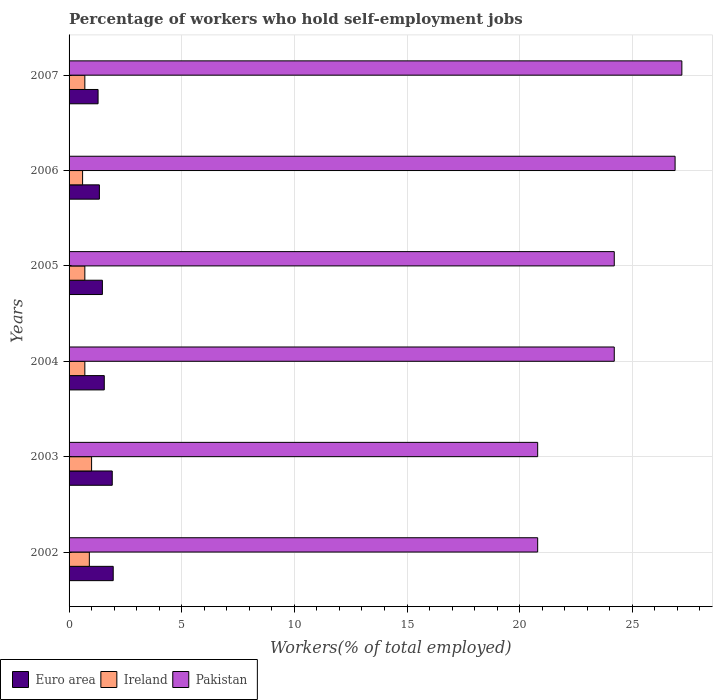How many different coloured bars are there?
Make the answer very short. 3. How many bars are there on the 2nd tick from the top?
Make the answer very short. 3. What is the percentage of self-employed workers in Pakistan in 2007?
Offer a very short reply. 27.2. Across all years, what is the minimum percentage of self-employed workers in Ireland?
Ensure brevity in your answer.  0.6. In which year was the percentage of self-employed workers in Ireland minimum?
Your answer should be compact. 2006. What is the total percentage of self-employed workers in Euro area in the graph?
Your answer should be very brief. 9.55. What is the difference between the percentage of self-employed workers in Euro area in 2003 and the percentage of self-employed workers in Ireland in 2002?
Provide a short and direct response. 1.02. What is the average percentage of self-employed workers in Euro area per year?
Give a very brief answer. 1.59. In the year 2004, what is the difference between the percentage of self-employed workers in Euro area and percentage of self-employed workers in Pakistan?
Your answer should be very brief. -22.64. What is the ratio of the percentage of self-employed workers in Pakistan in 2002 to that in 2004?
Provide a succinct answer. 0.86. Is the percentage of self-employed workers in Pakistan in 2002 less than that in 2006?
Offer a very short reply. Yes. What is the difference between the highest and the second highest percentage of self-employed workers in Ireland?
Ensure brevity in your answer.  0.1. What is the difference between the highest and the lowest percentage of self-employed workers in Euro area?
Ensure brevity in your answer.  0.67. What does the 1st bar from the bottom in 2006 represents?
Your answer should be very brief. Euro area. How many bars are there?
Make the answer very short. 18. Does the graph contain grids?
Your answer should be very brief. Yes. Where does the legend appear in the graph?
Your answer should be compact. Bottom left. What is the title of the graph?
Give a very brief answer. Percentage of workers who hold self-employment jobs. What is the label or title of the X-axis?
Your answer should be very brief. Workers(% of total employed). What is the label or title of the Y-axis?
Your answer should be compact. Years. What is the Workers(% of total employed) in Euro area in 2002?
Your response must be concise. 1.96. What is the Workers(% of total employed) of Ireland in 2002?
Ensure brevity in your answer.  0.9. What is the Workers(% of total employed) in Pakistan in 2002?
Offer a terse response. 20.8. What is the Workers(% of total employed) in Euro area in 2003?
Ensure brevity in your answer.  1.92. What is the Workers(% of total employed) of Pakistan in 2003?
Your answer should be very brief. 20.8. What is the Workers(% of total employed) of Euro area in 2004?
Give a very brief answer. 1.56. What is the Workers(% of total employed) of Ireland in 2004?
Make the answer very short. 0.7. What is the Workers(% of total employed) in Pakistan in 2004?
Ensure brevity in your answer.  24.2. What is the Workers(% of total employed) of Euro area in 2005?
Provide a short and direct response. 1.48. What is the Workers(% of total employed) of Ireland in 2005?
Make the answer very short. 0.7. What is the Workers(% of total employed) in Pakistan in 2005?
Provide a short and direct response. 24.2. What is the Workers(% of total employed) of Euro area in 2006?
Make the answer very short. 1.35. What is the Workers(% of total employed) in Ireland in 2006?
Your answer should be compact. 0.6. What is the Workers(% of total employed) of Pakistan in 2006?
Your answer should be very brief. 26.9. What is the Workers(% of total employed) of Euro area in 2007?
Provide a succinct answer. 1.29. What is the Workers(% of total employed) of Ireland in 2007?
Make the answer very short. 0.7. What is the Workers(% of total employed) of Pakistan in 2007?
Your answer should be compact. 27.2. Across all years, what is the maximum Workers(% of total employed) of Euro area?
Ensure brevity in your answer.  1.96. Across all years, what is the maximum Workers(% of total employed) of Pakistan?
Offer a very short reply. 27.2. Across all years, what is the minimum Workers(% of total employed) of Euro area?
Offer a terse response. 1.29. Across all years, what is the minimum Workers(% of total employed) of Ireland?
Provide a short and direct response. 0.6. Across all years, what is the minimum Workers(% of total employed) of Pakistan?
Keep it short and to the point. 20.8. What is the total Workers(% of total employed) in Euro area in the graph?
Give a very brief answer. 9.55. What is the total Workers(% of total employed) of Ireland in the graph?
Provide a succinct answer. 4.6. What is the total Workers(% of total employed) in Pakistan in the graph?
Ensure brevity in your answer.  144.1. What is the difference between the Workers(% of total employed) in Euro area in 2002 and that in 2003?
Your response must be concise. 0.04. What is the difference between the Workers(% of total employed) of Pakistan in 2002 and that in 2003?
Ensure brevity in your answer.  0. What is the difference between the Workers(% of total employed) in Euro area in 2002 and that in 2004?
Keep it short and to the point. 0.4. What is the difference between the Workers(% of total employed) of Euro area in 2002 and that in 2005?
Your answer should be very brief. 0.48. What is the difference between the Workers(% of total employed) in Euro area in 2002 and that in 2006?
Provide a short and direct response. 0.61. What is the difference between the Workers(% of total employed) in Pakistan in 2002 and that in 2006?
Your answer should be very brief. -6.1. What is the difference between the Workers(% of total employed) in Euro area in 2002 and that in 2007?
Your answer should be compact. 0.67. What is the difference between the Workers(% of total employed) of Ireland in 2002 and that in 2007?
Provide a short and direct response. 0.2. What is the difference between the Workers(% of total employed) in Pakistan in 2002 and that in 2007?
Your answer should be very brief. -6.4. What is the difference between the Workers(% of total employed) of Euro area in 2003 and that in 2004?
Provide a short and direct response. 0.35. What is the difference between the Workers(% of total employed) of Ireland in 2003 and that in 2004?
Provide a short and direct response. 0.3. What is the difference between the Workers(% of total employed) in Euro area in 2003 and that in 2005?
Your answer should be compact. 0.44. What is the difference between the Workers(% of total employed) in Ireland in 2003 and that in 2005?
Ensure brevity in your answer.  0.3. What is the difference between the Workers(% of total employed) of Pakistan in 2003 and that in 2005?
Give a very brief answer. -3.4. What is the difference between the Workers(% of total employed) in Euro area in 2003 and that in 2006?
Your response must be concise. 0.57. What is the difference between the Workers(% of total employed) in Euro area in 2003 and that in 2007?
Offer a very short reply. 0.63. What is the difference between the Workers(% of total employed) in Euro area in 2004 and that in 2005?
Offer a terse response. 0.08. What is the difference between the Workers(% of total employed) in Ireland in 2004 and that in 2005?
Your answer should be compact. 0. What is the difference between the Workers(% of total employed) of Euro area in 2004 and that in 2006?
Offer a very short reply. 0.22. What is the difference between the Workers(% of total employed) of Ireland in 2004 and that in 2006?
Make the answer very short. 0.1. What is the difference between the Workers(% of total employed) in Pakistan in 2004 and that in 2006?
Make the answer very short. -2.7. What is the difference between the Workers(% of total employed) in Euro area in 2004 and that in 2007?
Offer a terse response. 0.28. What is the difference between the Workers(% of total employed) in Pakistan in 2004 and that in 2007?
Give a very brief answer. -3. What is the difference between the Workers(% of total employed) in Euro area in 2005 and that in 2006?
Offer a very short reply. 0.13. What is the difference between the Workers(% of total employed) in Ireland in 2005 and that in 2006?
Give a very brief answer. 0.1. What is the difference between the Workers(% of total employed) of Euro area in 2005 and that in 2007?
Your response must be concise. 0.19. What is the difference between the Workers(% of total employed) in Ireland in 2005 and that in 2007?
Your response must be concise. 0. What is the difference between the Workers(% of total employed) of Euro area in 2006 and that in 2007?
Your answer should be very brief. 0.06. What is the difference between the Workers(% of total employed) in Ireland in 2006 and that in 2007?
Provide a short and direct response. -0.1. What is the difference between the Workers(% of total employed) of Euro area in 2002 and the Workers(% of total employed) of Ireland in 2003?
Provide a succinct answer. 0.96. What is the difference between the Workers(% of total employed) of Euro area in 2002 and the Workers(% of total employed) of Pakistan in 2003?
Your answer should be compact. -18.84. What is the difference between the Workers(% of total employed) of Ireland in 2002 and the Workers(% of total employed) of Pakistan in 2003?
Your answer should be compact. -19.9. What is the difference between the Workers(% of total employed) of Euro area in 2002 and the Workers(% of total employed) of Ireland in 2004?
Keep it short and to the point. 1.26. What is the difference between the Workers(% of total employed) of Euro area in 2002 and the Workers(% of total employed) of Pakistan in 2004?
Your answer should be compact. -22.24. What is the difference between the Workers(% of total employed) in Ireland in 2002 and the Workers(% of total employed) in Pakistan in 2004?
Offer a terse response. -23.3. What is the difference between the Workers(% of total employed) of Euro area in 2002 and the Workers(% of total employed) of Ireland in 2005?
Your answer should be compact. 1.26. What is the difference between the Workers(% of total employed) of Euro area in 2002 and the Workers(% of total employed) of Pakistan in 2005?
Give a very brief answer. -22.24. What is the difference between the Workers(% of total employed) in Ireland in 2002 and the Workers(% of total employed) in Pakistan in 2005?
Offer a terse response. -23.3. What is the difference between the Workers(% of total employed) in Euro area in 2002 and the Workers(% of total employed) in Ireland in 2006?
Your answer should be compact. 1.36. What is the difference between the Workers(% of total employed) in Euro area in 2002 and the Workers(% of total employed) in Pakistan in 2006?
Your answer should be compact. -24.94. What is the difference between the Workers(% of total employed) in Ireland in 2002 and the Workers(% of total employed) in Pakistan in 2006?
Your answer should be very brief. -26. What is the difference between the Workers(% of total employed) in Euro area in 2002 and the Workers(% of total employed) in Ireland in 2007?
Keep it short and to the point. 1.26. What is the difference between the Workers(% of total employed) in Euro area in 2002 and the Workers(% of total employed) in Pakistan in 2007?
Provide a succinct answer. -25.24. What is the difference between the Workers(% of total employed) of Ireland in 2002 and the Workers(% of total employed) of Pakistan in 2007?
Offer a terse response. -26.3. What is the difference between the Workers(% of total employed) in Euro area in 2003 and the Workers(% of total employed) in Ireland in 2004?
Make the answer very short. 1.22. What is the difference between the Workers(% of total employed) in Euro area in 2003 and the Workers(% of total employed) in Pakistan in 2004?
Make the answer very short. -22.28. What is the difference between the Workers(% of total employed) in Ireland in 2003 and the Workers(% of total employed) in Pakistan in 2004?
Give a very brief answer. -23.2. What is the difference between the Workers(% of total employed) in Euro area in 2003 and the Workers(% of total employed) in Ireland in 2005?
Give a very brief answer. 1.22. What is the difference between the Workers(% of total employed) of Euro area in 2003 and the Workers(% of total employed) of Pakistan in 2005?
Provide a succinct answer. -22.28. What is the difference between the Workers(% of total employed) in Ireland in 2003 and the Workers(% of total employed) in Pakistan in 2005?
Offer a terse response. -23.2. What is the difference between the Workers(% of total employed) of Euro area in 2003 and the Workers(% of total employed) of Ireland in 2006?
Your answer should be compact. 1.32. What is the difference between the Workers(% of total employed) in Euro area in 2003 and the Workers(% of total employed) in Pakistan in 2006?
Provide a succinct answer. -24.98. What is the difference between the Workers(% of total employed) of Ireland in 2003 and the Workers(% of total employed) of Pakistan in 2006?
Your response must be concise. -25.9. What is the difference between the Workers(% of total employed) of Euro area in 2003 and the Workers(% of total employed) of Ireland in 2007?
Your response must be concise. 1.22. What is the difference between the Workers(% of total employed) of Euro area in 2003 and the Workers(% of total employed) of Pakistan in 2007?
Give a very brief answer. -25.28. What is the difference between the Workers(% of total employed) in Ireland in 2003 and the Workers(% of total employed) in Pakistan in 2007?
Make the answer very short. -26.2. What is the difference between the Workers(% of total employed) of Euro area in 2004 and the Workers(% of total employed) of Ireland in 2005?
Offer a very short reply. 0.86. What is the difference between the Workers(% of total employed) of Euro area in 2004 and the Workers(% of total employed) of Pakistan in 2005?
Keep it short and to the point. -22.64. What is the difference between the Workers(% of total employed) in Ireland in 2004 and the Workers(% of total employed) in Pakistan in 2005?
Offer a terse response. -23.5. What is the difference between the Workers(% of total employed) of Euro area in 2004 and the Workers(% of total employed) of Ireland in 2006?
Provide a succinct answer. 0.96. What is the difference between the Workers(% of total employed) in Euro area in 2004 and the Workers(% of total employed) in Pakistan in 2006?
Make the answer very short. -25.34. What is the difference between the Workers(% of total employed) in Ireland in 2004 and the Workers(% of total employed) in Pakistan in 2006?
Provide a succinct answer. -26.2. What is the difference between the Workers(% of total employed) of Euro area in 2004 and the Workers(% of total employed) of Ireland in 2007?
Ensure brevity in your answer.  0.86. What is the difference between the Workers(% of total employed) in Euro area in 2004 and the Workers(% of total employed) in Pakistan in 2007?
Provide a short and direct response. -25.64. What is the difference between the Workers(% of total employed) of Ireland in 2004 and the Workers(% of total employed) of Pakistan in 2007?
Ensure brevity in your answer.  -26.5. What is the difference between the Workers(% of total employed) in Euro area in 2005 and the Workers(% of total employed) in Ireland in 2006?
Give a very brief answer. 0.88. What is the difference between the Workers(% of total employed) of Euro area in 2005 and the Workers(% of total employed) of Pakistan in 2006?
Ensure brevity in your answer.  -25.42. What is the difference between the Workers(% of total employed) of Ireland in 2005 and the Workers(% of total employed) of Pakistan in 2006?
Your answer should be compact. -26.2. What is the difference between the Workers(% of total employed) in Euro area in 2005 and the Workers(% of total employed) in Ireland in 2007?
Offer a terse response. 0.78. What is the difference between the Workers(% of total employed) of Euro area in 2005 and the Workers(% of total employed) of Pakistan in 2007?
Offer a terse response. -25.72. What is the difference between the Workers(% of total employed) of Ireland in 2005 and the Workers(% of total employed) of Pakistan in 2007?
Give a very brief answer. -26.5. What is the difference between the Workers(% of total employed) of Euro area in 2006 and the Workers(% of total employed) of Ireland in 2007?
Give a very brief answer. 0.65. What is the difference between the Workers(% of total employed) in Euro area in 2006 and the Workers(% of total employed) in Pakistan in 2007?
Your answer should be compact. -25.85. What is the difference between the Workers(% of total employed) of Ireland in 2006 and the Workers(% of total employed) of Pakistan in 2007?
Offer a terse response. -26.6. What is the average Workers(% of total employed) of Euro area per year?
Offer a very short reply. 1.59. What is the average Workers(% of total employed) of Ireland per year?
Offer a terse response. 0.77. What is the average Workers(% of total employed) in Pakistan per year?
Offer a terse response. 24.02. In the year 2002, what is the difference between the Workers(% of total employed) of Euro area and Workers(% of total employed) of Ireland?
Offer a very short reply. 1.06. In the year 2002, what is the difference between the Workers(% of total employed) of Euro area and Workers(% of total employed) of Pakistan?
Offer a terse response. -18.84. In the year 2002, what is the difference between the Workers(% of total employed) of Ireland and Workers(% of total employed) of Pakistan?
Keep it short and to the point. -19.9. In the year 2003, what is the difference between the Workers(% of total employed) of Euro area and Workers(% of total employed) of Ireland?
Offer a very short reply. 0.92. In the year 2003, what is the difference between the Workers(% of total employed) of Euro area and Workers(% of total employed) of Pakistan?
Your answer should be very brief. -18.88. In the year 2003, what is the difference between the Workers(% of total employed) in Ireland and Workers(% of total employed) in Pakistan?
Offer a terse response. -19.8. In the year 2004, what is the difference between the Workers(% of total employed) of Euro area and Workers(% of total employed) of Ireland?
Your answer should be compact. 0.86. In the year 2004, what is the difference between the Workers(% of total employed) of Euro area and Workers(% of total employed) of Pakistan?
Your response must be concise. -22.64. In the year 2004, what is the difference between the Workers(% of total employed) of Ireland and Workers(% of total employed) of Pakistan?
Keep it short and to the point. -23.5. In the year 2005, what is the difference between the Workers(% of total employed) in Euro area and Workers(% of total employed) in Ireland?
Your answer should be compact. 0.78. In the year 2005, what is the difference between the Workers(% of total employed) of Euro area and Workers(% of total employed) of Pakistan?
Your answer should be compact. -22.72. In the year 2005, what is the difference between the Workers(% of total employed) of Ireland and Workers(% of total employed) of Pakistan?
Offer a terse response. -23.5. In the year 2006, what is the difference between the Workers(% of total employed) of Euro area and Workers(% of total employed) of Ireland?
Ensure brevity in your answer.  0.75. In the year 2006, what is the difference between the Workers(% of total employed) in Euro area and Workers(% of total employed) in Pakistan?
Ensure brevity in your answer.  -25.55. In the year 2006, what is the difference between the Workers(% of total employed) in Ireland and Workers(% of total employed) in Pakistan?
Provide a succinct answer. -26.3. In the year 2007, what is the difference between the Workers(% of total employed) in Euro area and Workers(% of total employed) in Ireland?
Your answer should be compact. 0.59. In the year 2007, what is the difference between the Workers(% of total employed) of Euro area and Workers(% of total employed) of Pakistan?
Make the answer very short. -25.91. In the year 2007, what is the difference between the Workers(% of total employed) in Ireland and Workers(% of total employed) in Pakistan?
Keep it short and to the point. -26.5. What is the ratio of the Workers(% of total employed) in Euro area in 2002 to that in 2003?
Offer a terse response. 1.02. What is the ratio of the Workers(% of total employed) of Ireland in 2002 to that in 2003?
Offer a terse response. 0.9. What is the ratio of the Workers(% of total employed) in Pakistan in 2002 to that in 2003?
Keep it short and to the point. 1. What is the ratio of the Workers(% of total employed) of Euro area in 2002 to that in 2004?
Provide a succinct answer. 1.25. What is the ratio of the Workers(% of total employed) in Pakistan in 2002 to that in 2004?
Provide a short and direct response. 0.86. What is the ratio of the Workers(% of total employed) of Euro area in 2002 to that in 2005?
Make the answer very short. 1.33. What is the ratio of the Workers(% of total employed) in Ireland in 2002 to that in 2005?
Ensure brevity in your answer.  1.29. What is the ratio of the Workers(% of total employed) in Pakistan in 2002 to that in 2005?
Make the answer very short. 0.86. What is the ratio of the Workers(% of total employed) in Euro area in 2002 to that in 2006?
Make the answer very short. 1.46. What is the ratio of the Workers(% of total employed) in Pakistan in 2002 to that in 2006?
Offer a terse response. 0.77. What is the ratio of the Workers(% of total employed) in Euro area in 2002 to that in 2007?
Make the answer very short. 1.52. What is the ratio of the Workers(% of total employed) of Ireland in 2002 to that in 2007?
Keep it short and to the point. 1.29. What is the ratio of the Workers(% of total employed) in Pakistan in 2002 to that in 2007?
Provide a short and direct response. 0.76. What is the ratio of the Workers(% of total employed) in Euro area in 2003 to that in 2004?
Your answer should be compact. 1.23. What is the ratio of the Workers(% of total employed) in Ireland in 2003 to that in 2004?
Provide a short and direct response. 1.43. What is the ratio of the Workers(% of total employed) in Pakistan in 2003 to that in 2004?
Your answer should be very brief. 0.86. What is the ratio of the Workers(% of total employed) of Euro area in 2003 to that in 2005?
Ensure brevity in your answer.  1.3. What is the ratio of the Workers(% of total employed) in Ireland in 2003 to that in 2005?
Ensure brevity in your answer.  1.43. What is the ratio of the Workers(% of total employed) in Pakistan in 2003 to that in 2005?
Offer a terse response. 0.86. What is the ratio of the Workers(% of total employed) in Euro area in 2003 to that in 2006?
Ensure brevity in your answer.  1.42. What is the ratio of the Workers(% of total employed) in Ireland in 2003 to that in 2006?
Provide a succinct answer. 1.67. What is the ratio of the Workers(% of total employed) of Pakistan in 2003 to that in 2006?
Keep it short and to the point. 0.77. What is the ratio of the Workers(% of total employed) in Euro area in 2003 to that in 2007?
Your answer should be compact. 1.49. What is the ratio of the Workers(% of total employed) in Ireland in 2003 to that in 2007?
Keep it short and to the point. 1.43. What is the ratio of the Workers(% of total employed) of Pakistan in 2003 to that in 2007?
Your response must be concise. 0.76. What is the ratio of the Workers(% of total employed) in Euro area in 2004 to that in 2005?
Keep it short and to the point. 1.06. What is the ratio of the Workers(% of total employed) of Pakistan in 2004 to that in 2005?
Your answer should be compact. 1. What is the ratio of the Workers(% of total employed) in Euro area in 2004 to that in 2006?
Ensure brevity in your answer.  1.16. What is the ratio of the Workers(% of total employed) in Ireland in 2004 to that in 2006?
Make the answer very short. 1.17. What is the ratio of the Workers(% of total employed) in Pakistan in 2004 to that in 2006?
Your response must be concise. 0.9. What is the ratio of the Workers(% of total employed) in Euro area in 2004 to that in 2007?
Your response must be concise. 1.21. What is the ratio of the Workers(% of total employed) in Pakistan in 2004 to that in 2007?
Offer a terse response. 0.89. What is the ratio of the Workers(% of total employed) in Euro area in 2005 to that in 2006?
Your answer should be compact. 1.1. What is the ratio of the Workers(% of total employed) of Ireland in 2005 to that in 2006?
Your response must be concise. 1.17. What is the ratio of the Workers(% of total employed) of Pakistan in 2005 to that in 2006?
Provide a succinct answer. 0.9. What is the ratio of the Workers(% of total employed) of Euro area in 2005 to that in 2007?
Ensure brevity in your answer.  1.15. What is the ratio of the Workers(% of total employed) of Pakistan in 2005 to that in 2007?
Offer a terse response. 0.89. What is the ratio of the Workers(% of total employed) in Euro area in 2006 to that in 2007?
Make the answer very short. 1.05. What is the ratio of the Workers(% of total employed) in Ireland in 2006 to that in 2007?
Your answer should be very brief. 0.86. What is the ratio of the Workers(% of total employed) in Pakistan in 2006 to that in 2007?
Make the answer very short. 0.99. What is the difference between the highest and the second highest Workers(% of total employed) in Euro area?
Offer a very short reply. 0.04. What is the difference between the highest and the second highest Workers(% of total employed) in Pakistan?
Offer a terse response. 0.3. What is the difference between the highest and the lowest Workers(% of total employed) of Euro area?
Your answer should be compact. 0.67. What is the difference between the highest and the lowest Workers(% of total employed) in Ireland?
Ensure brevity in your answer.  0.4. What is the difference between the highest and the lowest Workers(% of total employed) of Pakistan?
Offer a terse response. 6.4. 